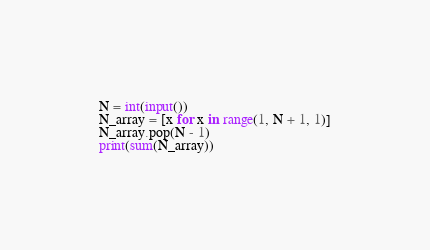Convert code to text. <code><loc_0><loc_0><loc_500><loc_500><_Python_>N = int(input())
N_array = [x for x in range(1, N + 1, 1)]
N_array.pop(N - 1)
print(sum(N_array))</code> 